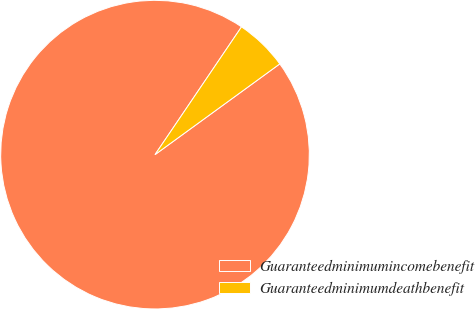Convert chart. <chart><loc_0><loc_0><loc_500><loc_500><pie_chart><fcel>Guaranteedminimumincomebenefit<fcel>Guaranteedminimumdeathbenefit<nl><fcel>94.48%<fcel>5.52%<nl></chart> 